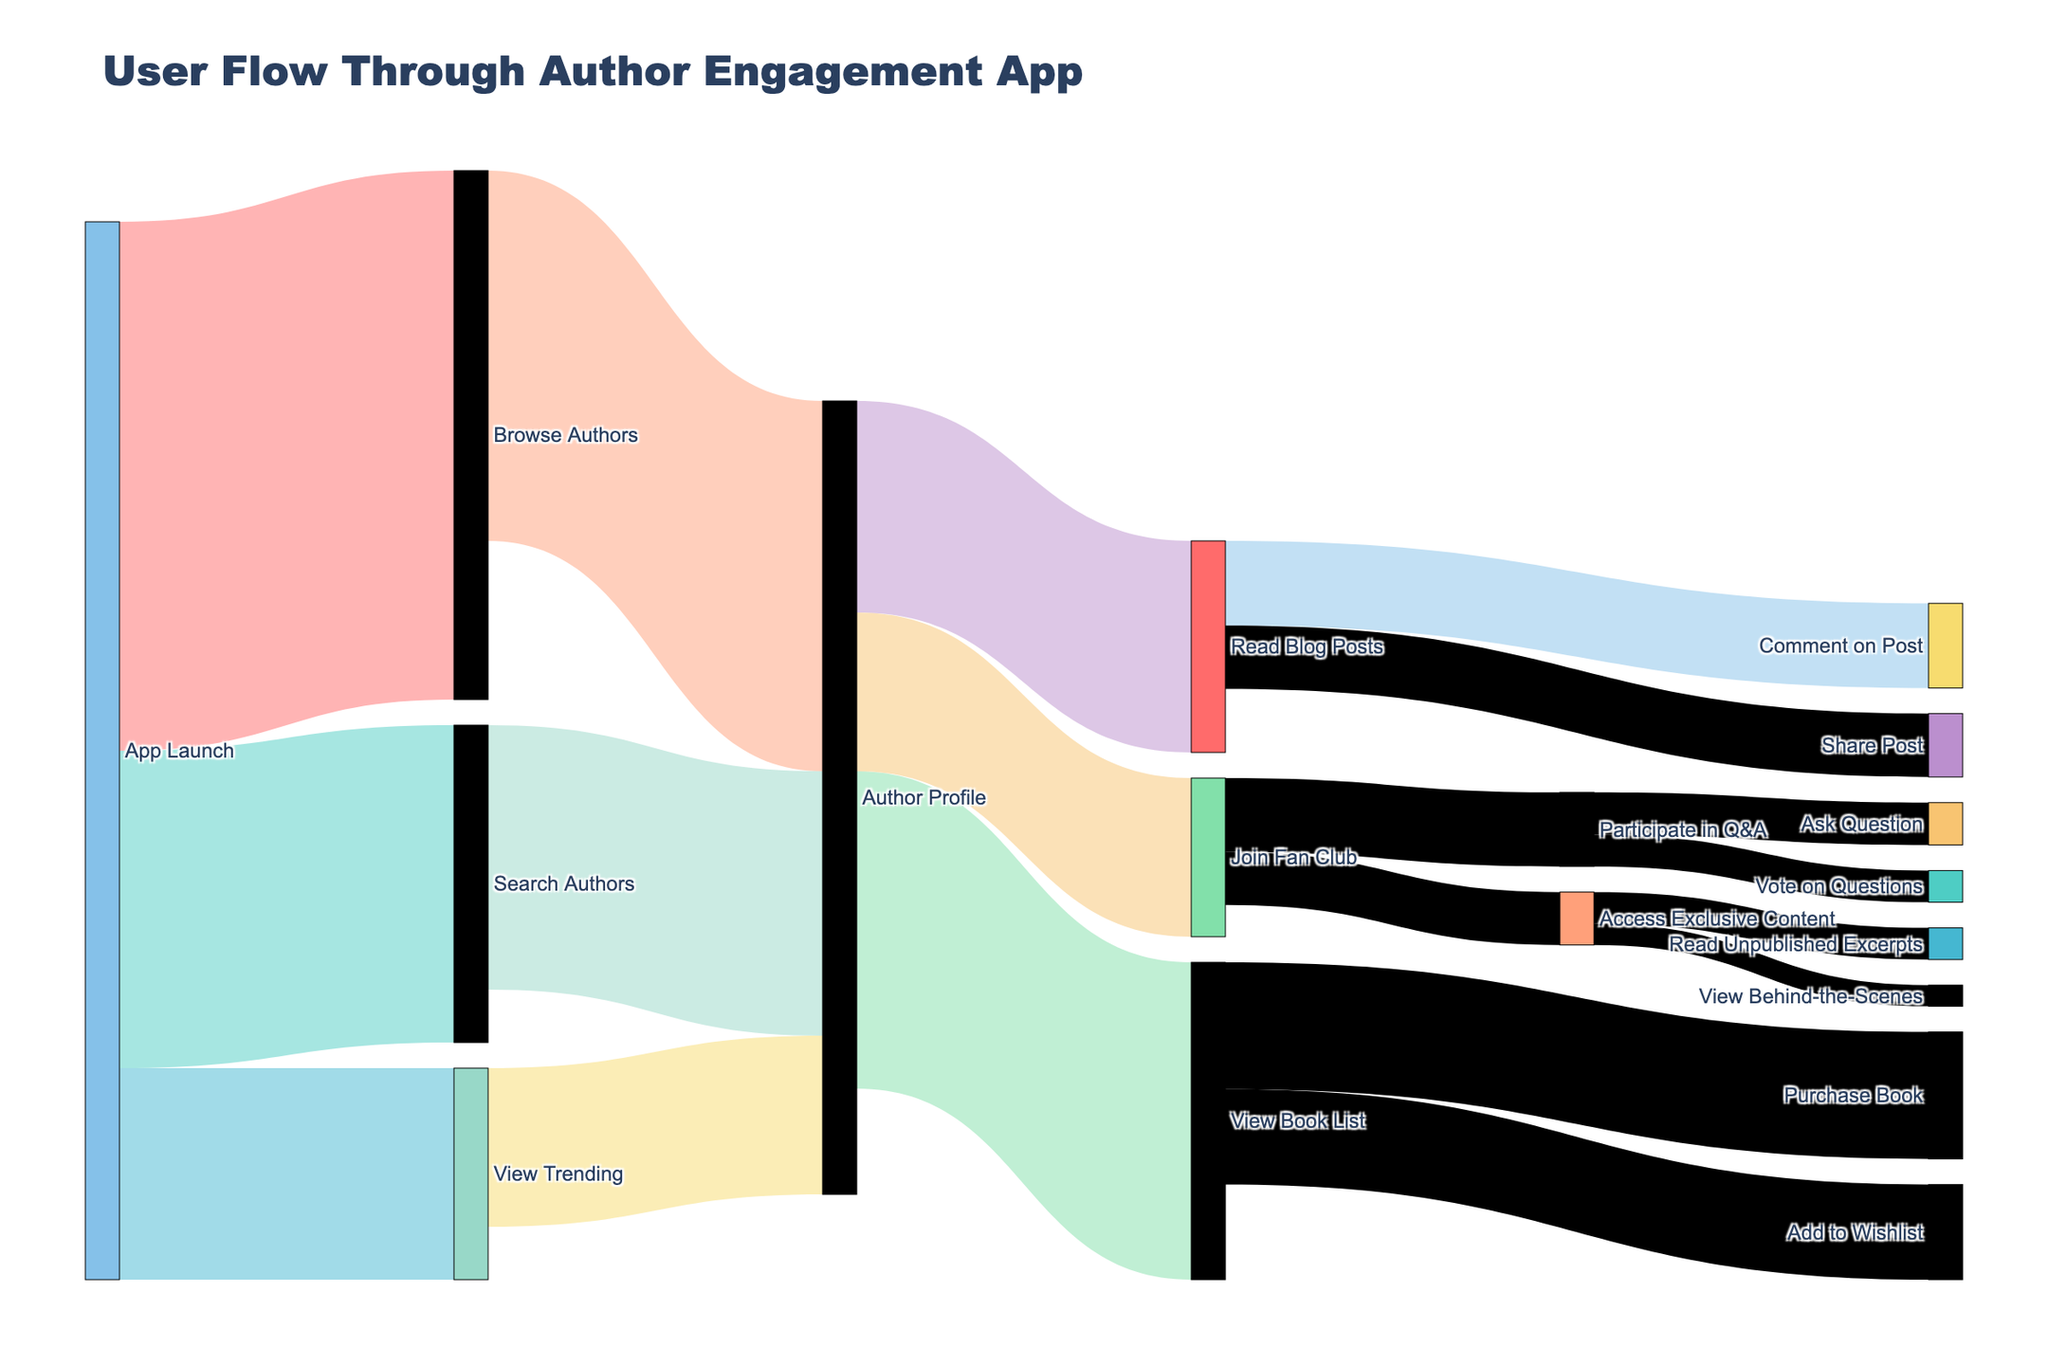Which path has the highest starting interaction from the app launch? The total number of users starting from the app launch can be checked in the figure. By examining the paths starting from "App Launch", we see that "Browse Authors" has the highest interaction with 5000 users.
Answer: Browse Authors Which action has the fewest interactions after "Author Profile"? We need to look at the paths originating from "Author Profile". "Join Fan Club" sees the fewest interactions with 1500 users.
Answer: Join Fan Club What’s the total number of users that interact with "Author Profile" from all sources? Add the number of users reaching "Author Profile" from "Browse Authors" (3500), "Search Authors" (2500), and "View Trending" (1500). The total is 3500 + 2500 + 1500 = 7500.
Answer: 7500 How many users purchased a book after viewing the book list? From the "View Book List" path, "Purchase Book" shows 1200 users made a purchase.
Answer: 1200 Do more users comment on or share blog posts after reading them? Comparing "Comment on Post" (800 users) and "Share Post" (600 users) from the "Read Blog Posts" path, more users comment.
Answer: Comment on Post What is the most common final interaction after "Join Fan Club"? Examine the paths originating from "Join Fan Club" and note their values. "Participate in Q&A" has the highest interaction with 700 users.
Answer: Participate in Q&A Which activity involves more users: Voting on Q&A questions or accessing unpublished excerpts? Compare "Vote on Questions" (300 users) from "Participate in Q&A" with "Read Unpublished Excerpts" (300 users) from "Access Exclusive Content". Both paths have 300 users.
Answer: Equal What's the total number of users who take actions related to exclusive content? Sum the users for "Read Unpublished Excerpts" (300) and "View Behind-the-Scenes" (200) from "Access Exclusive Content". The total is 300 + 200 = 500.
Answer: 500 How many users add books to their wishlists after viewing the book list? From the "View Book List" path, "Add to Wishlist" sees 900 users adding books.
Answer: 900 